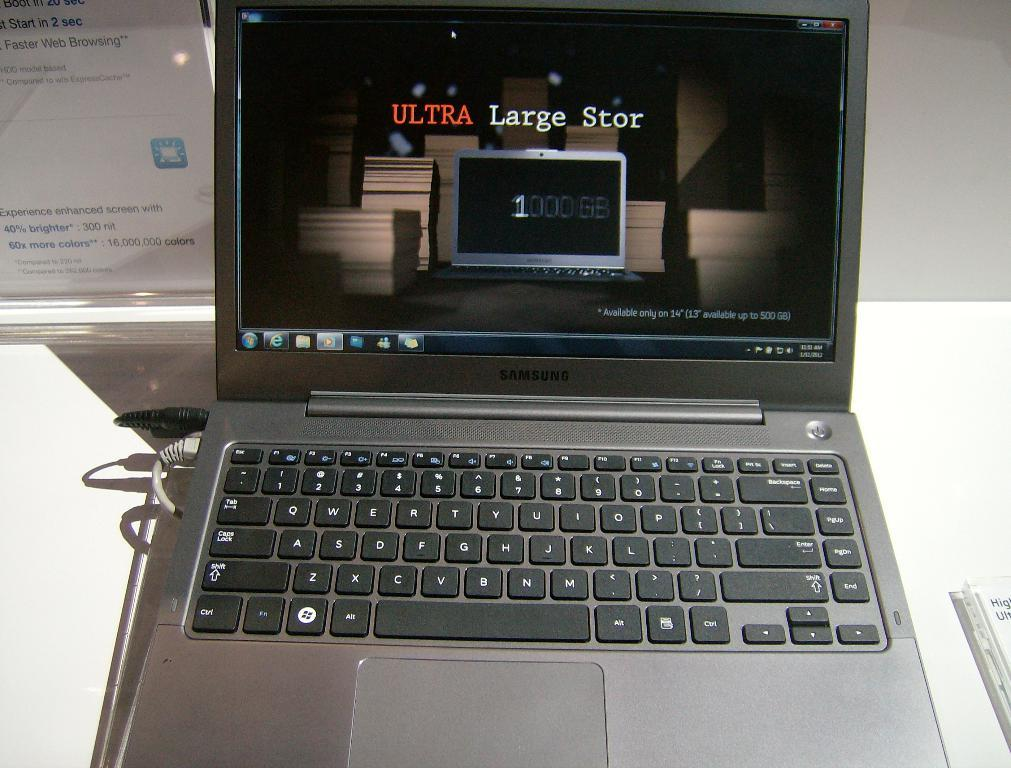Provide a one-sentence caption for the provided image. A Samsung laptop sits open on a white surface. 